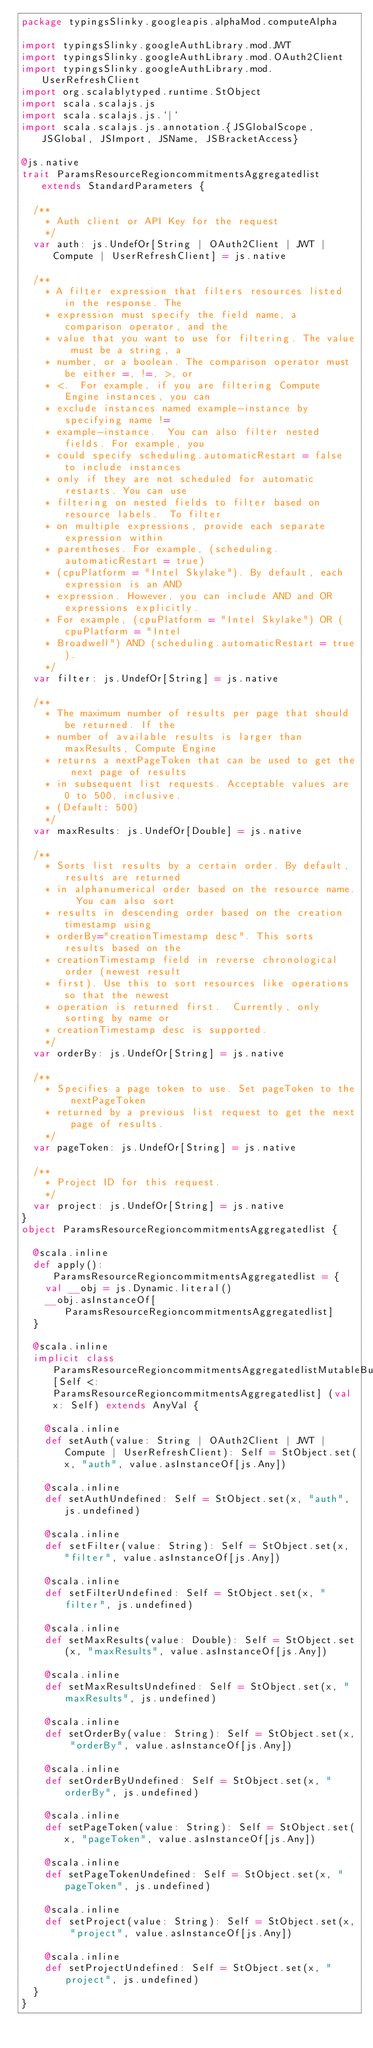<code> <loc_0><loc_0><loc_500><loc_500><_Scala_>package typingsSlinky.googleapis.alphaMod.computeAlpha

import typingsSlinky.googleAuthLibrary.mod.JWT
import typingsSlinky.googleAuthLibrary.mod.OAuth2Client
import typingsSlinky.googleAuthLibrary.mod.UserRefreshClient
import org.scalablytyped.runtime.StObject
import scala.scalajs.js
import scala.scalajs.js.`|`
import scala.scalajs.js.annotation.{JSGlobalScope, JSGlobal, JSImport, JSName, JSBracketAccess}

@js.native
trait ParamsResourceRegioncommitmentsAggregatedlist extends StandardParameters {
  
  /**
    * Auth client or API Key for the request
    */
  var auth: js.UndefOr[String | OAuth2Client | JWT | Compute | UserRefreshClient] = js.native
  
  /**
    * A filter expression that filters resources listed in the response. The
    * expression must specify the field name, a comparison operator, and the
    * value that you want to use for filtering. The value must be a string, a
    * number, or a boolean. The comparison operator must be either =, !=, >, or
    * <.  For example, if you are filtering Compute Engine instances, you can
    * exclude instances named example-instance by specifying name !=
    * example-instance.  You can also filter nested fields. For example, you
    * could specify scheduling.automaticRestart = false to include instances
    * only if they are not scheduled for automatic restarts. You can use
    * filtering on nested fields to filter based on resource labels.  To filter
    * on multiple expressions, provide each separate expression within
    * parentheses. For example, (scheduling.automaticRestart = true)
    * (cpuPlatform = "Intel Skylake"). By default, each expression is an AND
    * expression. However, you can include AND and OR expressions explicitly.
    * For example, (cpuPlatform = "Intel Skylake") OR (cpuPlatform = "Intel
    * Broadwell") AND (scheduling.automaticRestart = true).
    */
  var filter: js.UndefOr[String] = js.native
  
  /**
    * The maximum number of results per page that should be returned. If the
    * number of available results is larger than maxResults, Compute Engine
    * returns a nextPageToken that can be used to get the next page of results
    * in subsequent list requests. Acceptable values are 0 to 500, inclusive.
    * (Default: 500)
    */
  var maxResults: js.UndefOr[Double] = js.native
  
  /**
    * Sorts list results by a certain order. By default, results are returned
    * in alphanumerical order based on the resource name.  You can also sort
    * results in descending order based on the creation timestamp using
    * orderBy="creationTimestamp desc". This sorts results based on the
    * creationTimestamp field in reverse chronological order (newest result
    * first). Use this to sort resources like operations so that the newest
    * operation is returned first.  Currently, only sorting by name or
    * creationTimestamp desc is supported.
    */
  var orderBy: js.UndefOr[String] = js.native
  
  /**
    * Specifies a page token to use. Set pageToken to the nextPageToken
    * returned by a previous list request to get the next page of results.
    */
  var pageToken: js.UndefOr[String] = js.native
  
  /**
    * Project ID for this request.
    */
  var project: js.UndefOr[String] = js.native
}
object ParamsResourceRegioncommitmentsAggregatedlist {
  
  @scala.inline
  def apply(): ParamsResourceRegioncommitmentsAggregatedlist = {
    val __obj = js.Dynamic.literal()
    __obj.asInstanceOf[ParamsResourceRegioncommitmentsAggregatedlist]
  }
  
  @scala.inline
  implicit class ParamsResourceRegioncommitmentsAggregatedlistMutableBuilder[Self <: ParamsResourceRegioncommitmentsAggregatedlist] (val x: Self) extends AnyVal {
    
    @scala.inline
    def setAuth(value: String | OAuth2Client | JWT | Compute | UserRefreshClient): Self = StObject.set(x, "auth", value.asInstanceOf[js.Any])
    
    @scala.inline
    def setAuthUndefined: Self = StObject.set(x, "auth", js.undefined)
    
    @scala.inline
    def setFilter(value: String): Self = StObject.set(x, "filter", value.asInstanceOf[js.Any])
    
    @scala.inline
    def setFilterUndefined: Self = StObject.set(x, "filter", js.undefined)
    
    @scala.inline
    def setMaxResults(value: Double): Self = StObject.set(x, "maxResults", value.asInstanceOf[js.Any])
    
    @scala.inline
    def setMaxResultsUndefined: Self = StObject.set(x, "maxResults", js.undefined)
    
    @scala.inline
    def setOrderBy(value: String): Self = StObject.set(x, "orderBy", value.asInstanceOf[js.Any])
    
    @scala.inline
    def setOrderByUndefined: Self = StObject.set(x, "orderBy", js.undefined)
    
    @scala.inline
    def setPageToken(value: String): Self = StObject.set(x, "pageToken", value.asInstanceOf[js.Any])
    
    @scala.inline
    def setPageTokenUndefined: Self = StObject.set(x, "pageToken", js.undefined)
    
    @scala.inline
    def setProject(value: String): Self = StObject.set(x, "project", value.asInstanceOf[js.Any])
    
    @scala.inline
    def setProjectUndefined: Self = StObject.set(x, "project", js.undefined)
  }
}
</code> 